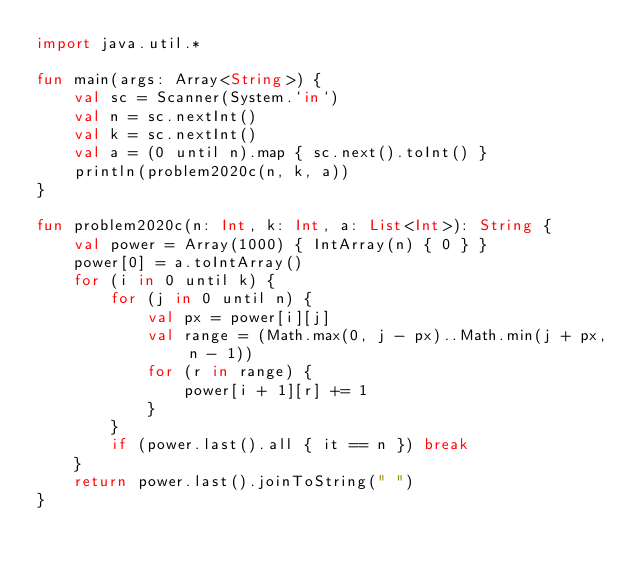Convert code to text. <code><loc_0><loc_0><loc_500><loc_500><_Kotlin_>import java.util.*

fun main(args: Array<String>) {
    val sc = Scanner(System.`in`)
    val n = sc.nextInt()
    val k = sc.nextInt()
    val a = (0 until n).map { sc.next().toInt() }
    println(problem2020c(n, k, a))
}

fun problem2020c(n: Int, k: Int, a: List<Int>): String {
    val power = Array(1000) { IntArray(n) { 0 } }
    power[0] = a.toIntArray()
    for (i in 0 until k) {
        for (j in 0 until n) {
            val px = power[i][j]
            val range = (Math.max(0, j - px)..Math.min(j + px, n - 1))
            for (r in range) {
                power[i + 1][r] += 1
            }
        }
        if (power.last().all { it == n }) break
    }
    return power.last().joinToString(" ")
}</code> 